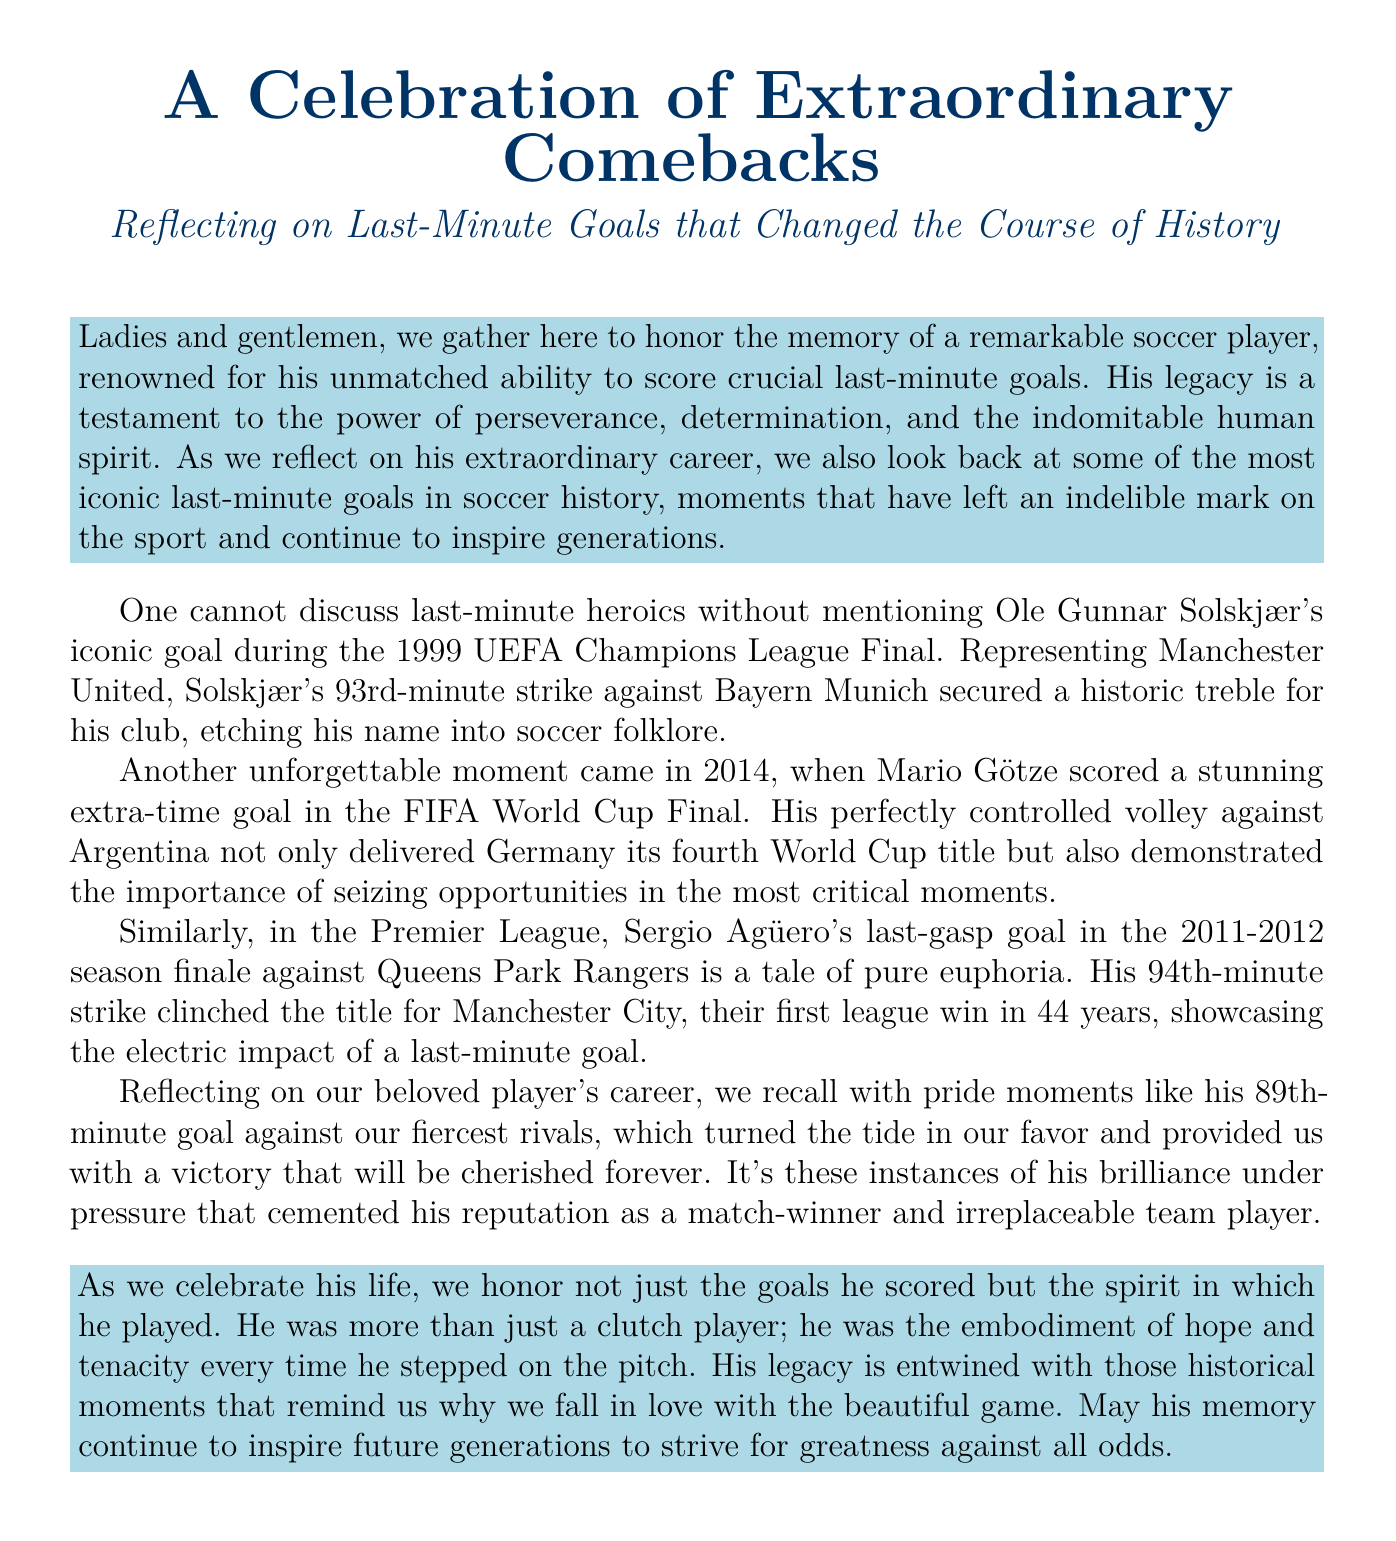What is the title of the document? The title of the document is clearly stated at the beginning, "A Celebration of Extraordinary Comebacks."
Answer: A Celebration of Extraordinary Comebacks Who scored the iconic goal in the 1999 UEFA Champions League Final? The document mentions Ole Gunnar Solskjær as the player who scored the iconic goal.
Answer: Ole Gunnar Solskjær What year did Mario Götze score in the FIFA World Cup Final? The document specifies the year when Mario Götze scored, which was 2014.
Answer: 2014 Which team was Sergio Agüero playing for when he scored his last-gasp goal? The document indicates that Sergio Agüero was playing for Manchester City at that time.
Answer: Manchester City What is the significance of Ole Gunnar Solskjær's goal? The document explains that his goal secured a historic treble for Manchester United.
Answer: Historic treble How many World Cup titles did Germany win with Götze's goal? The document states that Götze's goal delivered Germany its fourth World Cup title.
Answer: Fourth What does the document suggest about the player's legacy? The document describes the player as "the embodiment of hope and tenacity."
Answer: Embodiment of hope and tenacity What was the time of Agüero's famous goal against Queens Park Rangers? The document specifically mentions that his goal was scored in the 94th minute.
Answer: 94th minute What emotional quality is being celebrated in this eulogy? The document emphasizes the spirit of perseverance and determination throughout the eulogy.
Answer: Perseverance and determination 